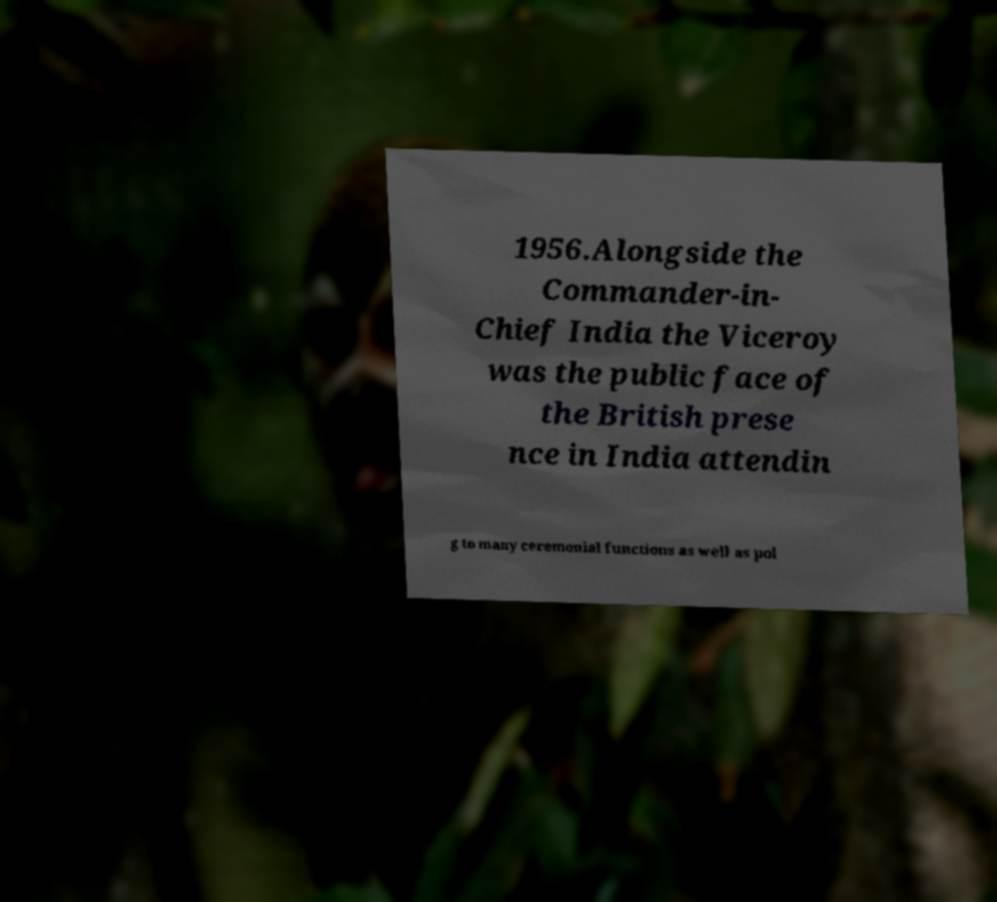What messages or text are displayed in this image? I need them in a readable, typed format. 1956.Alongside the Commander-in- Chief India the Viceroy was the public face of the British prese nce in India attendin g to many ceremonial functions as well as pol 